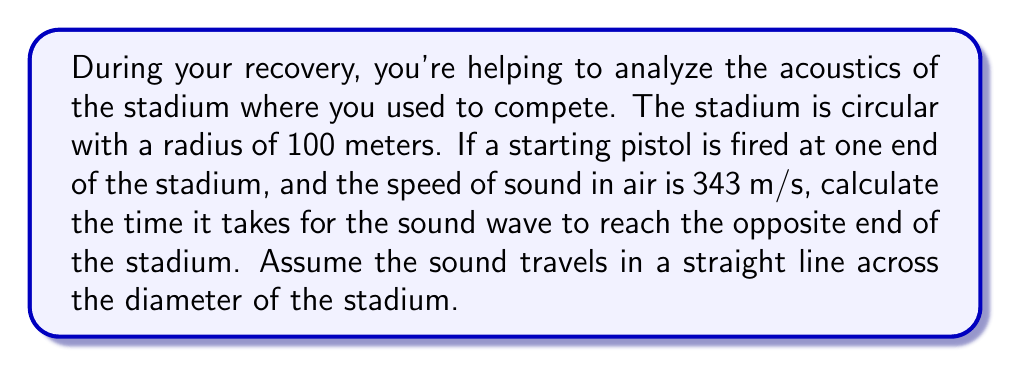Give your solution to this math problem. Let's approach this step-by-step:

1) First, we need to identify the relevant equation. For wave propagation, we use:

   $$v = \frac{d}{t}$$

   Where $v$ is the velocity (speed of sound), $d$ is the distance traveled, and $t$ is the time taken.

2) We're given the speed of sound in air: $v = 343$ m/s

3) For the distance, we need to calculate the diameter of the stadium. Since the radius is 100 meters, the diameter is:

   $$d = 2r = 2 * 100 = 200$$ meters

4) Now we can rearrange our equation to solve for time:

   $$t = \frac{d}{v}$$

5) Substituting our values:

   $$t = \frac{200 \text{ m}}{343 \text{ m/s}}$$

6) Calculating:

   $$t \approx 0.5831$$ seconds

Therefore, it takes approximately 0.5831 seconds for the sound to travel across the stadium.
Answer: $0.5831$ seconds 